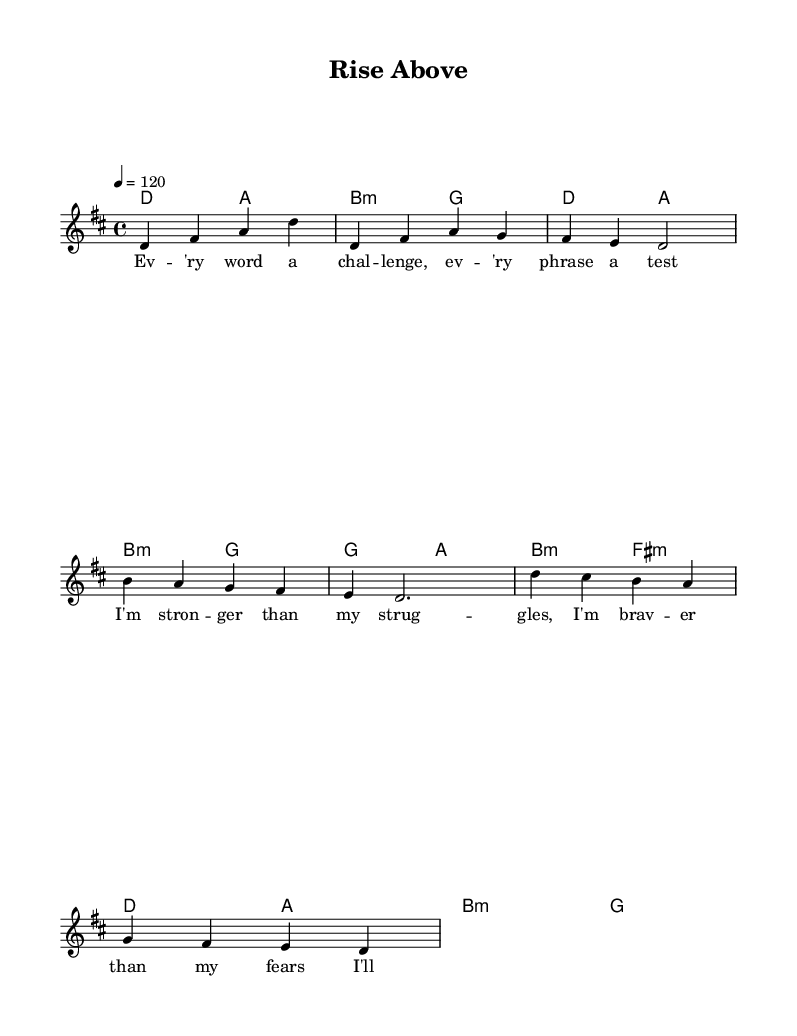What is the key signature of this music? The key signature is D major, indicated by the presence of two sharps (F# and C#) in the music sheet.
Answer: D major What is the time signature of this music? The time signature is 4/4, which means there are four beats in a measure, and the quarter note gets one beat.
Answer: 4/4 What is the tempo marking for this piece? The tempo marking is 120 beats per minute, indicated by the number 120 under the tempo marking section.
Answer: 120 How many measures are in the chorus section? The chorus section is comprised of 4 measures, as indicated by the grouping of bars with the melody notes.
Answer: 4 What is the first note of the verse? The first note of the verse is D, as shown in the melody part of the sheet music.
Answer: D What chord is played during the pre-chorus? The chord played during the pre-chorus section is G major, which is indicated in the harmonies section of the sheet music.
Answer: G major What is the theme of the lyrics in this piece? The theme of the lyrics is personal resilience and growth, as indicated by the words describing overcoming challenges and finding one's voice.
Answer: Personal resilience 